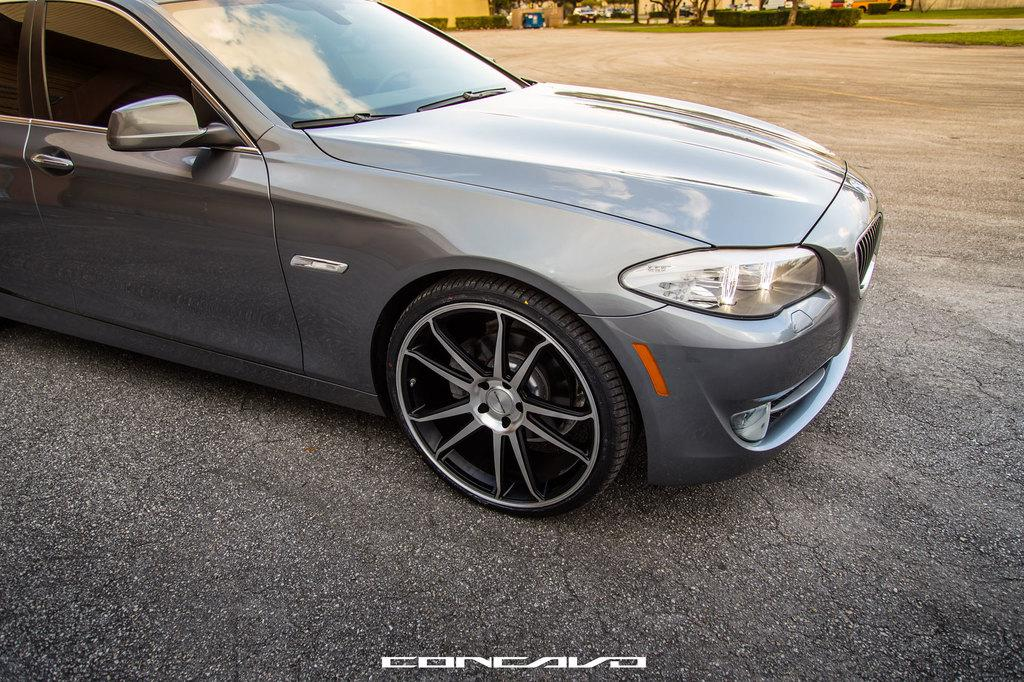What is the main subject in the front of the image? There is a car in the front of the image. What type of natural elements can be seen in the background of the image? There are plants and trees in the background of the image. What is the ground made of in the image? There is grass on the ground in the image. What type of man-made structure is visible in the background of the image? There is a wall in the background of the image. What scientific experiment is being conducted in the image? There is no scientific experiment visible in the image. How does the structure rest on the ground in the image? The structure, which is the wall, is not resting on the ground in the image; it is standing upright. 